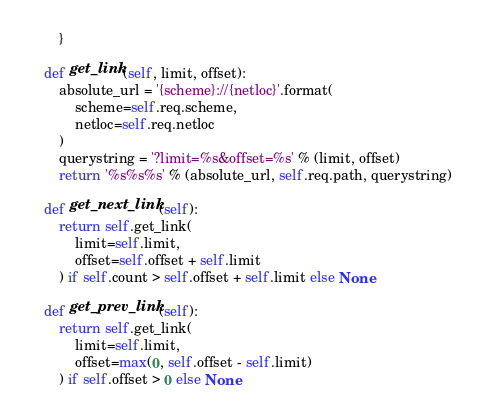<code> <loc_0><loc_0><loc_500><loc_500><_Python_>        }

    def get_link(self, limit, offset):
        absolute_url = '{scheme}://{netloc}'.format(
            scheme=self.req.scheme,
            netloc=self.req.netloc
        )
        querystring = '?limit=%s&offset=%s' % (limit, offset)
        return '%s%s%s' % (absolute_url, self.req.path, querystring)

    def get_next_link(self):
        return self.get_link(
            limit=self.limit,
            offset=self.offset + self.limit
        ) if self.count > self.offset + self.limit else None

    def get_prev_link(self):
        return self.get_link(
            limit=self.limit,
            offset=max(0, self.offset - self.limit)
        ) if self.offset > 0 else None
</code> 